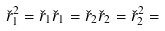<formula> <loc_0><loc_0><loc_500><loc_500>\check { r } _ { 1 } ^ { 2 } = \check { r } _ { 1 } \check { r } _ { 1 } = \check { r } _ { 2 } \check { r } _ { 2 } = \check { r } _ { 2 } ^ { 2 } =</formula> 